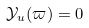Convert formula to latex. <formula><loc_0><loc_0><loc_500><loc_500>\mathcal { Y } _ { u } ( \varpi ) = 0</formula> 